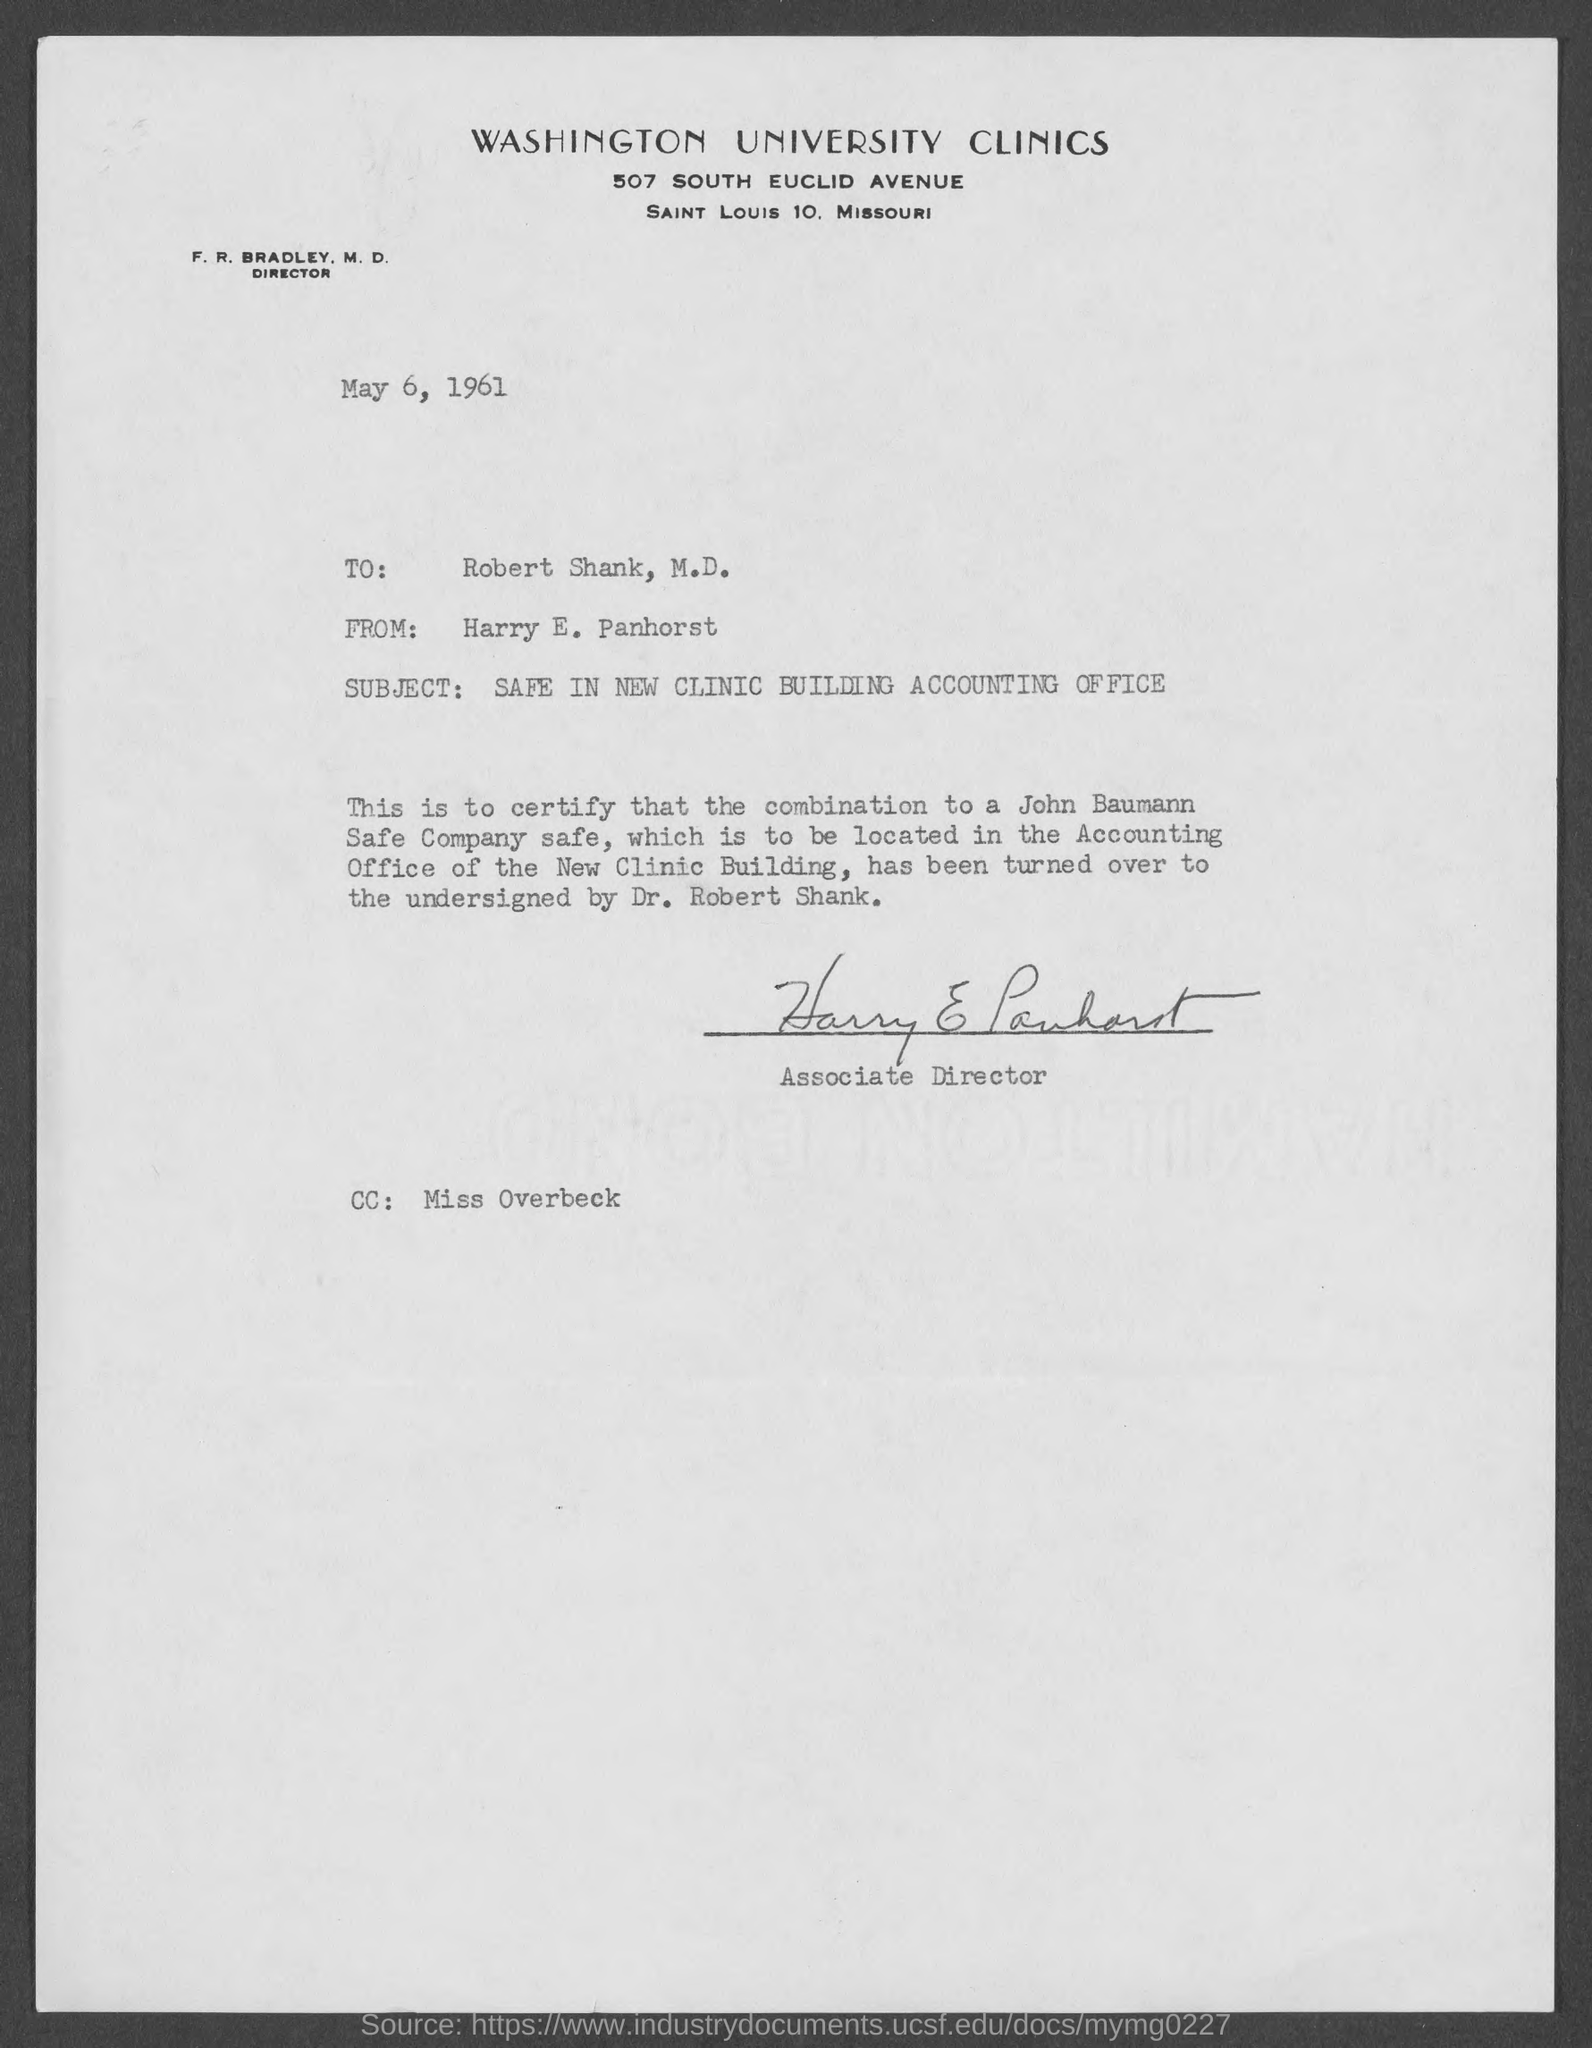Specify some key components in this picture. Harry E. Panhorst is the Associate Director. The subject of the letter is the safety of the new clinic building's accounting office. The letter is dated May 6, 1961. Washington University Clinics is located at 507 South Euclid Avenue. The letter is addressed to Robert Shank, M.D. 